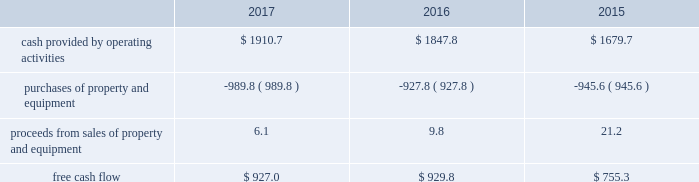Financial assurance we must provide financial assurance to governmental agencies and a variety of other entities under applicable environmental regulations relating to our landfill operations for capping , closure and post-closure costs , and related to our performance under certain collection , landfill and transfer station contracts .
We satisfy these financial assurance requirements by providing surety bonds , letters of credit , or insurance policies ( financial assurance instruments ) , or trust deposits , which are included in restricted cash and marketable securities and other assets in our consolidated balance sheets .
The amount of the financial assurance requirements for capping , closure and post-closure costs is determined by applicable state environmental regulations .
The financial assurance requirements for capping , closure and post-closure costs may be associated with a portion of the landfill or the entire landfill .
Generally , states require a third-party engineering specialist to determine the estimated capping , closure and post-closure costs that are used to determine the required amount of financial assurance for a landfill .
The amount of financial assurance required can , and generally will , differ from the obligation determined and recorded under u.s .
Gaap .
The amount of the financial assurance requirements related to contract performance varies by contract .
Additionally , we must provide financial assurance for our insurance program and collateral for certain performance obligations .
We do not expect a material increase in financial assurance requirements during 2018 , although the mix of financial assurance instruments may change .
These financial assurance instruments are issued in the normal course of business and are not considered indebtedness .
Because we currently have no liability for the financial assurance instruments , they are not reflected in our consolidated balance sheets ; however , we record capping , closure and post-closure liabilities and insurance liabilities as they are incurred .
Off-balance sheet arrangements we have no off-balance sheet debt or similar obligations , other than operating leases and financial assurances , which are not classified as debt .
We have no transactions or obligations with related parties that are not disclosed , consolidated into or reflected in our reported financial position or results of operations .
We have not guaranteed any third-party debt .
Free cash flow we define free cash flow , which is not a measure determined in accordance with u.s .
Gaap , as cash provided by operating activities less purchases of property and equipment , plus proceeds from sales of property and equipment , as presented in our consolidated statements of cash flows .
The table calculates our free cash flow for the years ended december 31 , 2017 , 2016 and 2015 ( in millions of dollars ) : .
For a discussion of the changes in the components of free cash flow , see our discussion regarding cash flows provided by operating activities and cash flows used in investing activities contained elsewhere in this management 2019s discussion and analysis of financial condition and results of operations. .
What is the percent change in free cash flow from 2015 to 2016? 
Rationale: the percentage change is equal to the difference in the amounts based on the recent and earliest divide by the earliest
Computations: ((929.8 - 755.3) / 755.3)
Answer: 0.23103. 